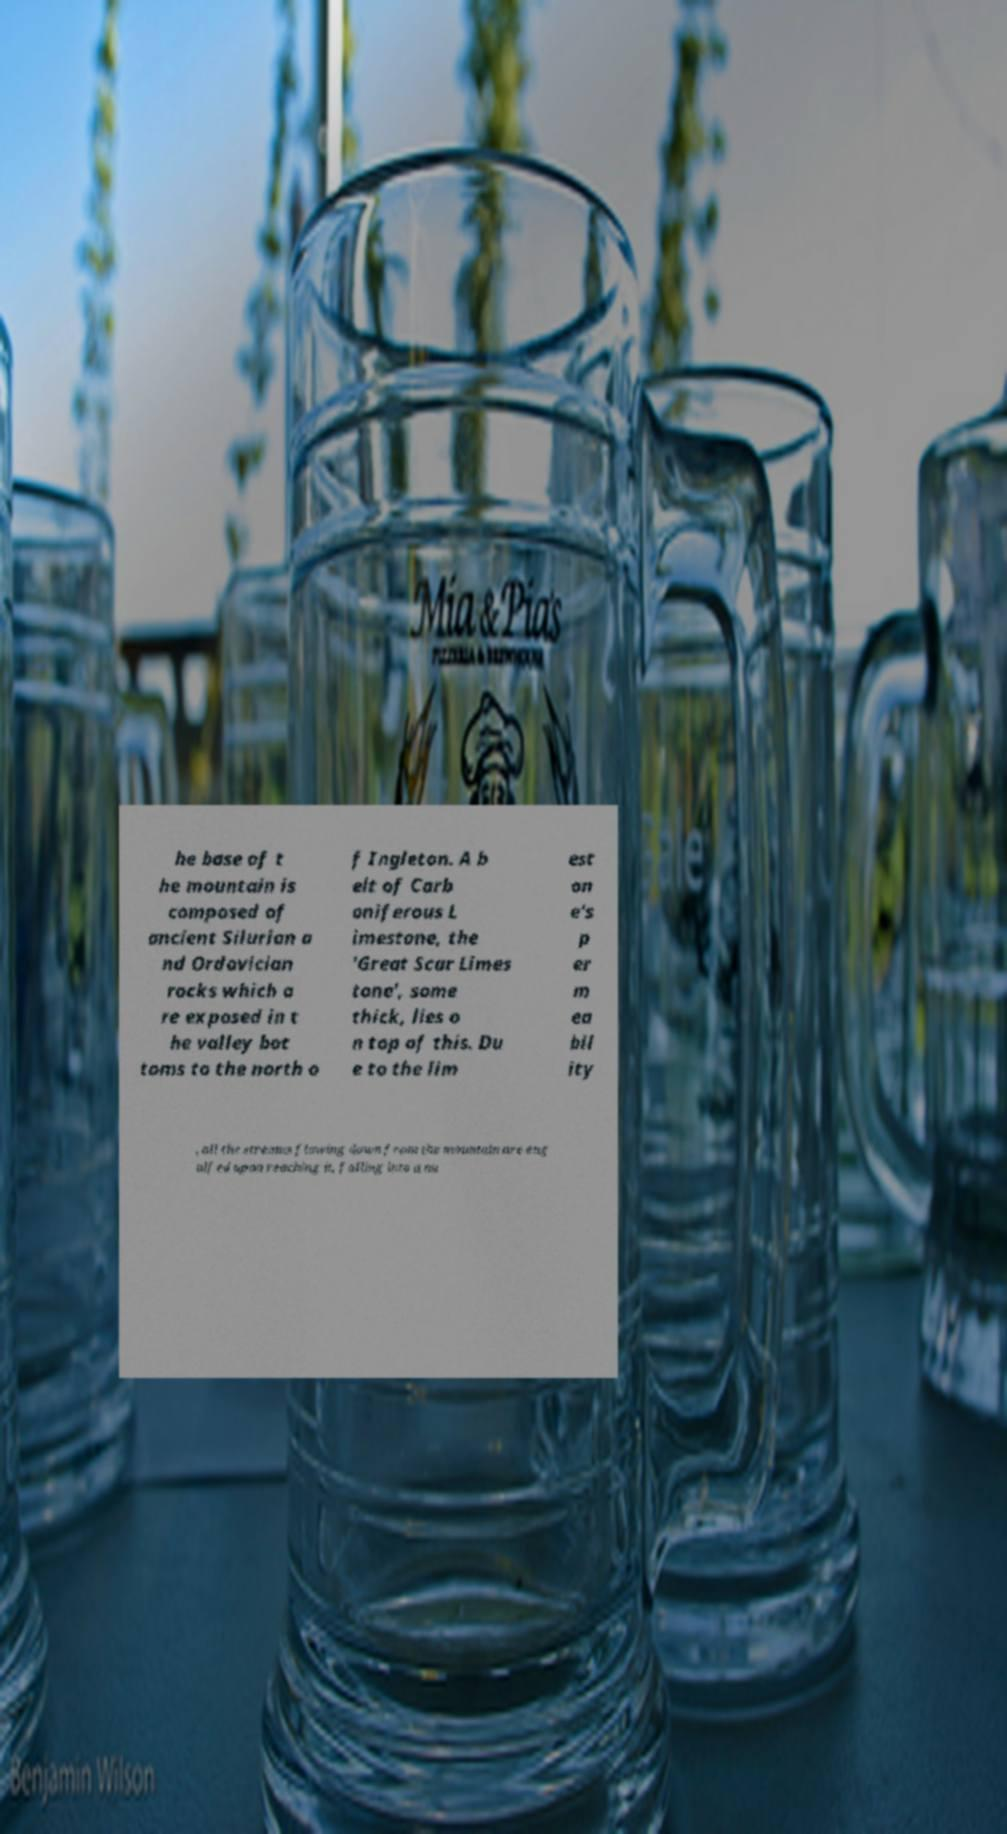Please identify and transcribe the text found in this image. he base of t he mountain is composed of ancient Silurian a nd Ordovician rocks which a re exposed in t he valley bot toms to the north o f Ingleton. A b elt of Carb oniferous L imestone, the 'Great Scar Limes tone', some thick, lies o n top of this. Du e to the lim est on e's p er m ea bil ity , all the streams flowing down from the mountain are eng ulfed upon reaching it, falling into a nu 